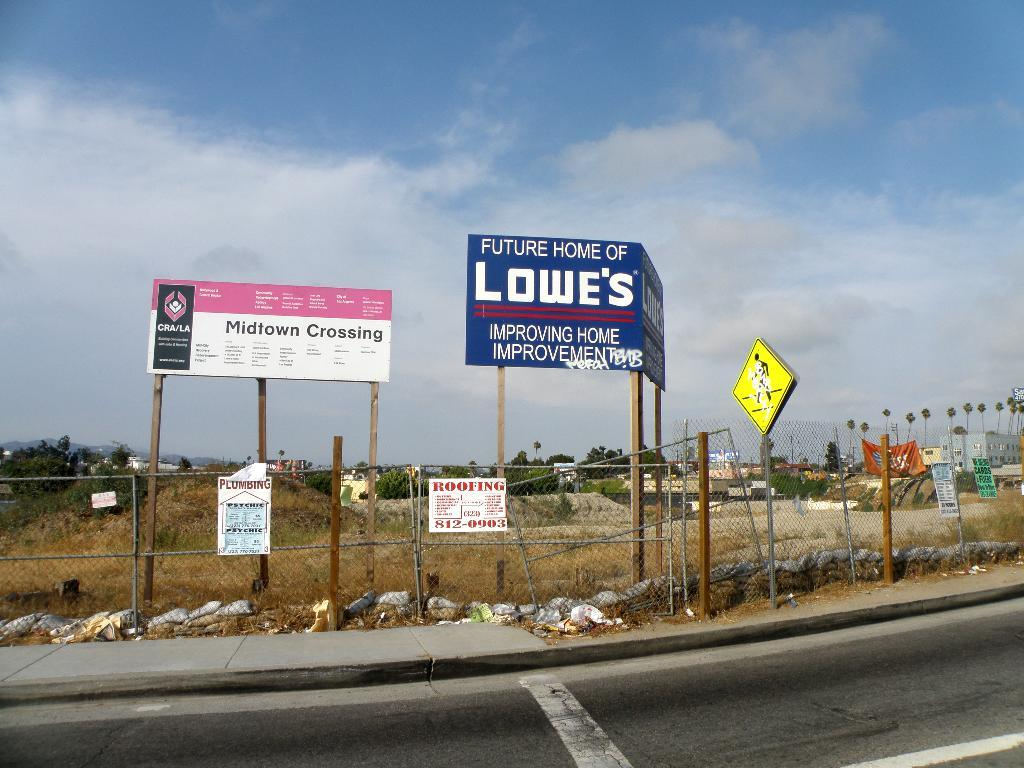<image>
Create a compact narrative representing the image presented. A billboard for Lowe's says that they're improving home improvement. 